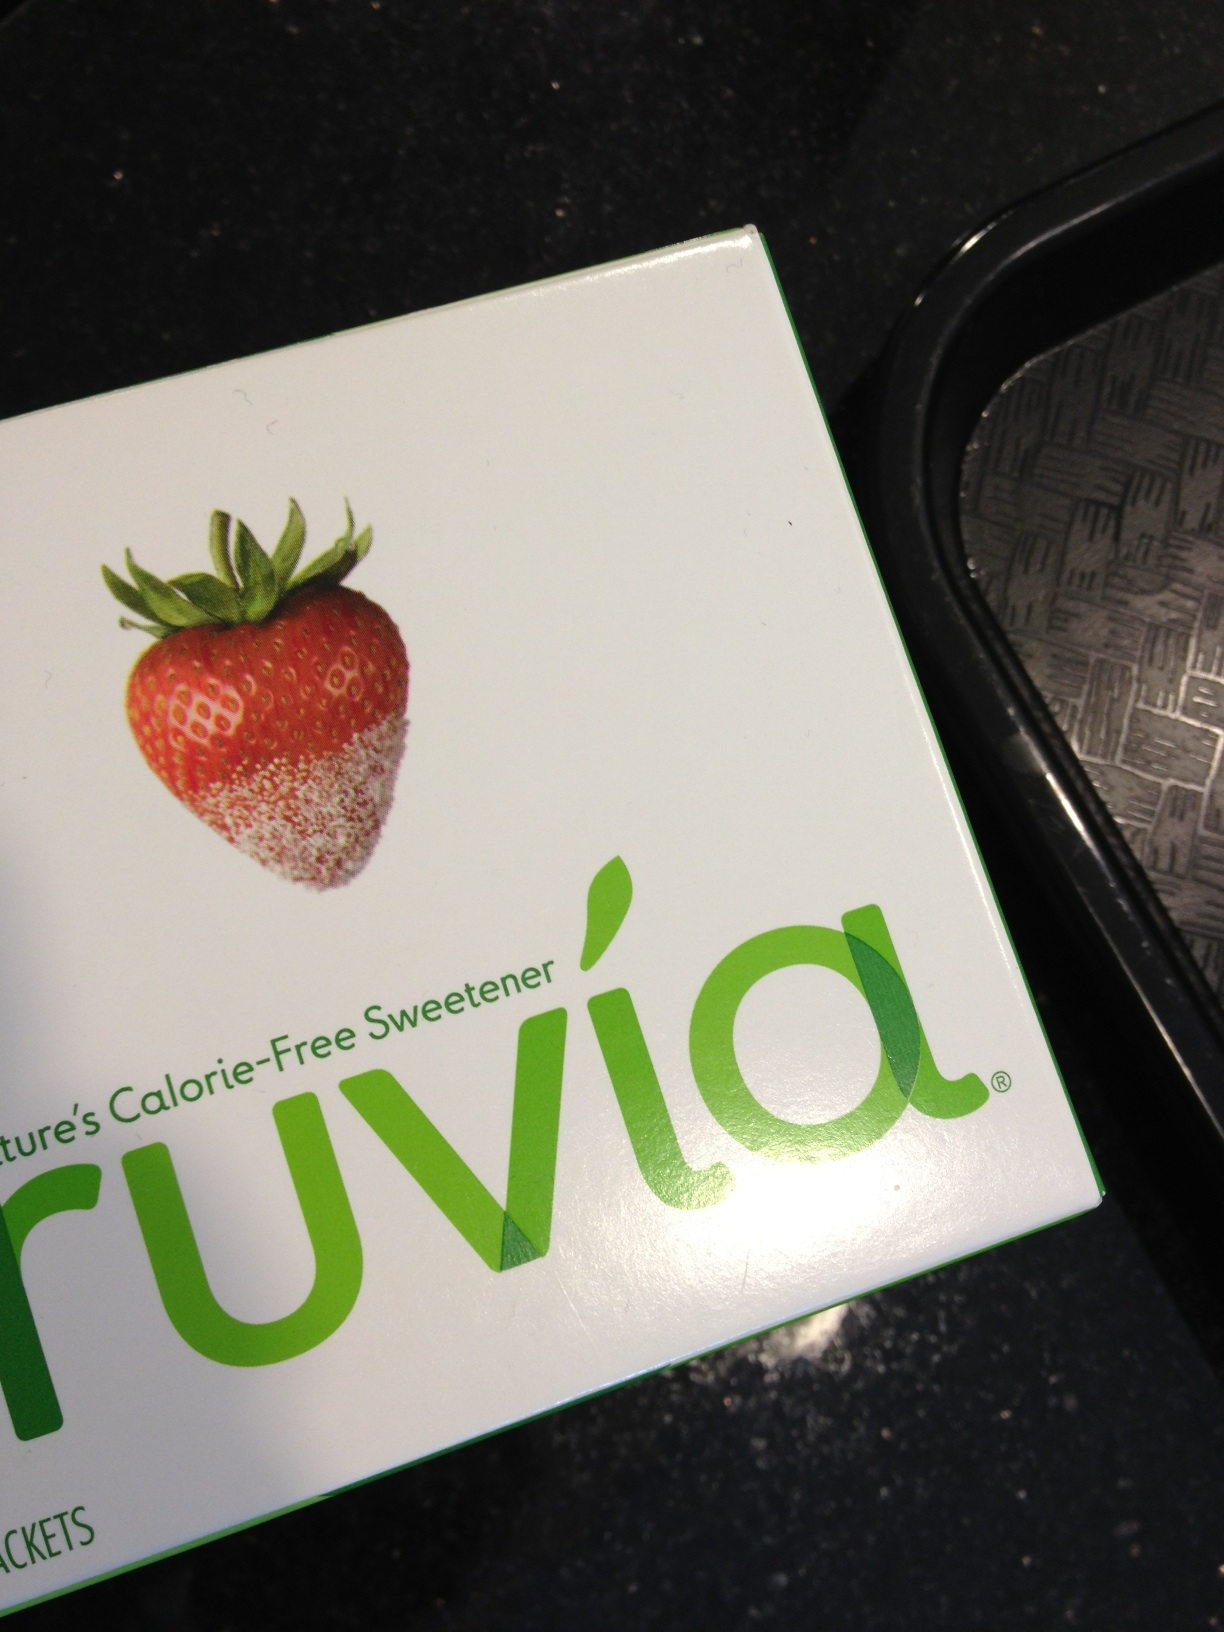Can you explain what Truvia is and what it's made from? Truvia is a natural, calorie-free sweetener derived from the stevia leaf, often used to sweeten foods and beverages. The main ingredients include stevia leaf extract, erythritol, which is a sugar alcohol, and other natural flavors. 